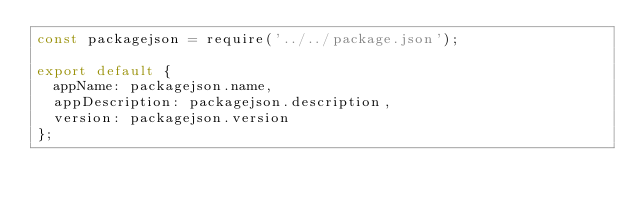Convert code to text. <code><loc_0><loc_0><loc_500><loc_500><_JavaScript_>const packagejson = require('../../package.json');

export default {
  appName: packagejson.name,
  appDescription: packagejson.description,
  version: packagejson.version
};
</code> 